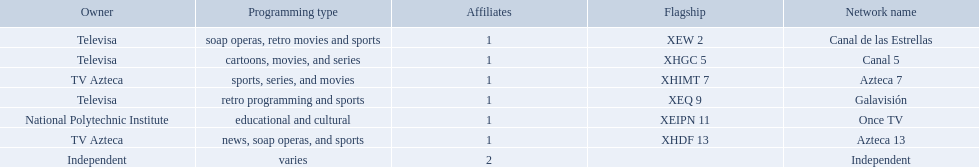What station shows cartoons? Canal 5. What station shows soap operas? Canal de las Estrellas. What station shows sports? Azteca 7. What stations show sports? Soap operas, retro movies and sports, retro programming and sports, news, soap operas, and sports. What of these is not affiliated with televisa? Azteca 7. 